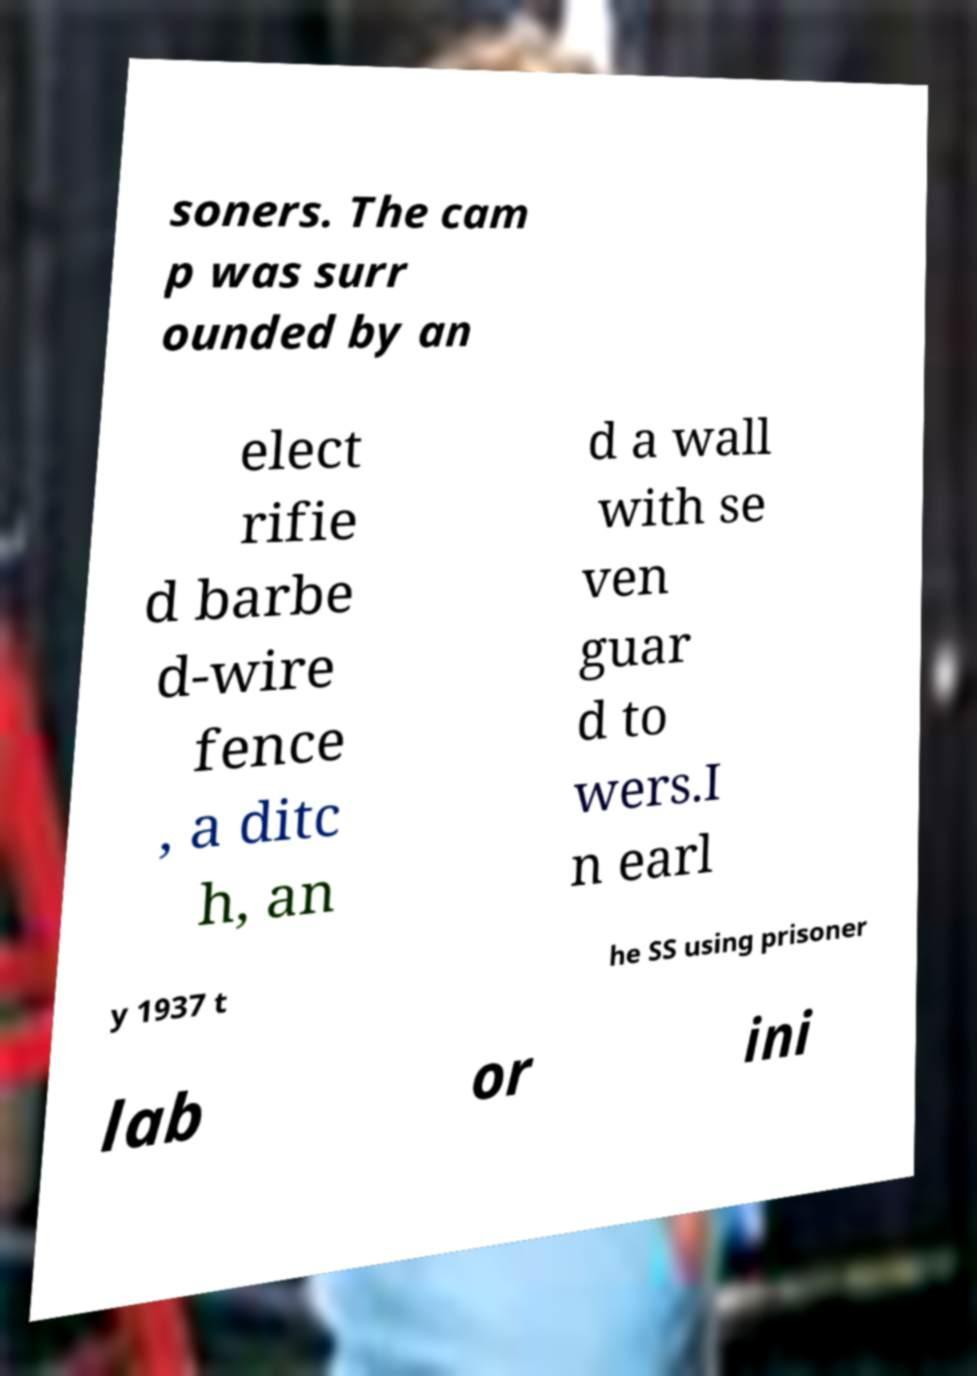Can you read and provide the text displayed in the image?This photo seems to have some interesting text. Can you extract and type it out for me? soners. The cam p was surr ounded by an elect rifie d barbe d-wire fence , a ditc h, an d a wall with se ven guar d to wers.I n earl y 1937 t he SS using prisoner lab or ini 